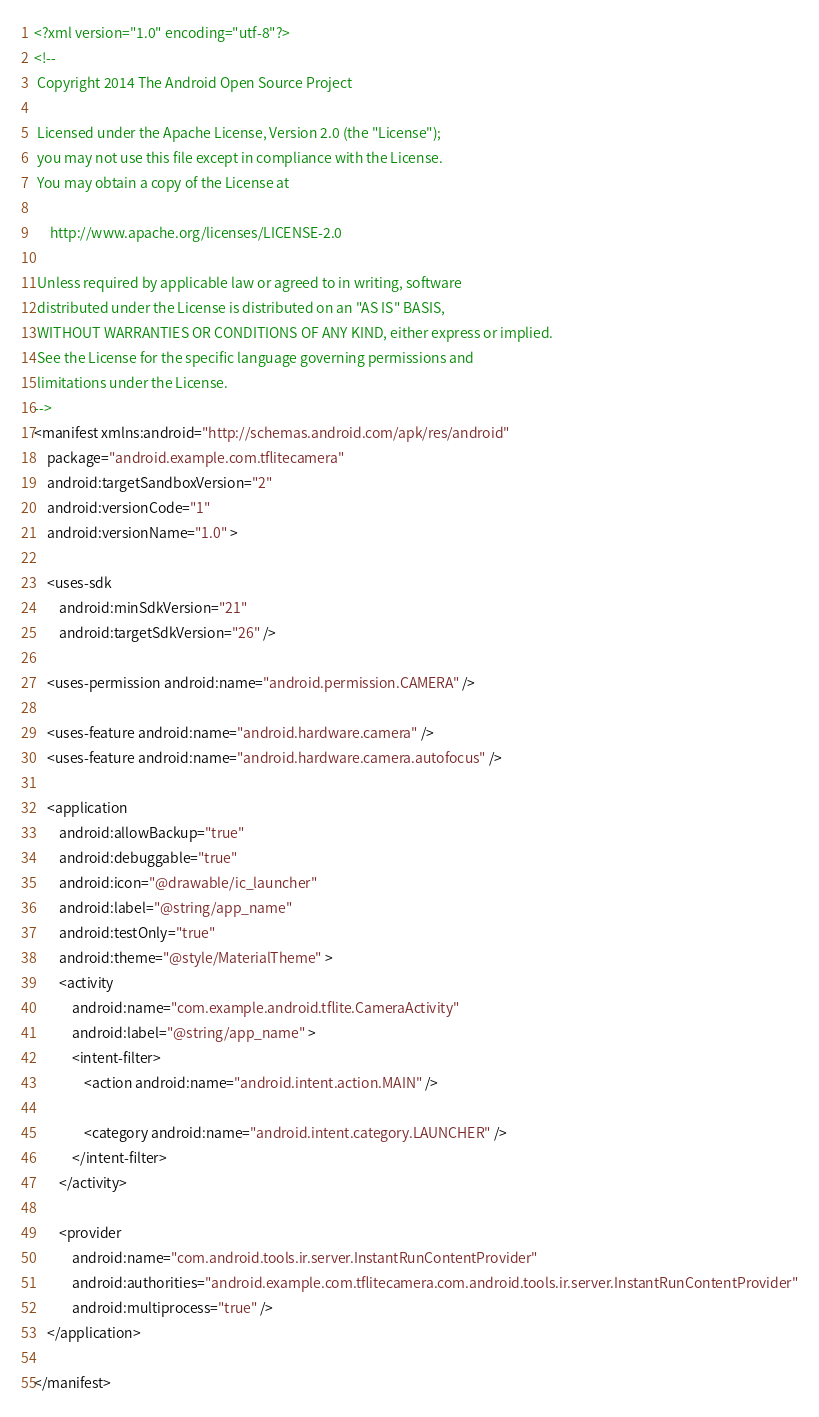<code> <loc_0><loc_0><loc_500><loc_500><_XML_><?xml version="1.0" encoding="utf-8"?>
<!--
 Copyright 2014 The Android Open Source Project

 Licensed under the Apache License, Version 2.0 (the "License");
 you may not use this file except in compliance with the License.
 You may obtain a copy of the License at

     http://www.apache.org/licenses/LICENSE-2.0

 Unless required by applicable law or agreed to in writing, software
 distributed under the License is distributed on an "AS IS" BASIS,
 WITHOUT WARRANTIES OR CONDITIONS OF ANY KIND, either express or implied.
 See the License for the specific language governing permissions and
 limitations under the License.
-->
<manifest xmlns:android="http://schemas.android.com/apk/res/android"
    package="android.example.com.tflitecamera"
    android:targetSandboxVersion="2"
    android:versionCode="1"
    android:versionName="1.0" >

    <uses-sdk
        android:minSdkVersion="21"
        android:targetSdkVersion="26" />

    <uses-permission android:name="android.permission.CAMERA" />

    <uses-feature android:name="android.hardware.camera" />
    <uses-feature android:name="android.hardware.camera.autofocus" />

    <application
        android:allowBackup="true"
        android:debuggable="true"
        android:icon="@drawable/ic_launcher"
        android:label="@string/app_name"
        android:testOnly="true"
        android:theme="@style/MaterialTheme" >
        <activity
            android:name="com.example.android.tflite.CameraActivity"
            android:label="@string/app_name" >
            <intent-filter>
                <action android:name="android.intent.action.MAIN" />

                <category android:name="android.intent.category.LAUNCHER" />
            </intent-filter>
        </activity>

        <provider
            android:name="com.android.tools.ir.server.InstantRunContentProvider"
            android:authorities="android.example.com.tflitecamera.com.android.tools.ir.server.InstantRunContentProvider"
            android:multiprocess="true" />
    </application>

</manifest></code> 